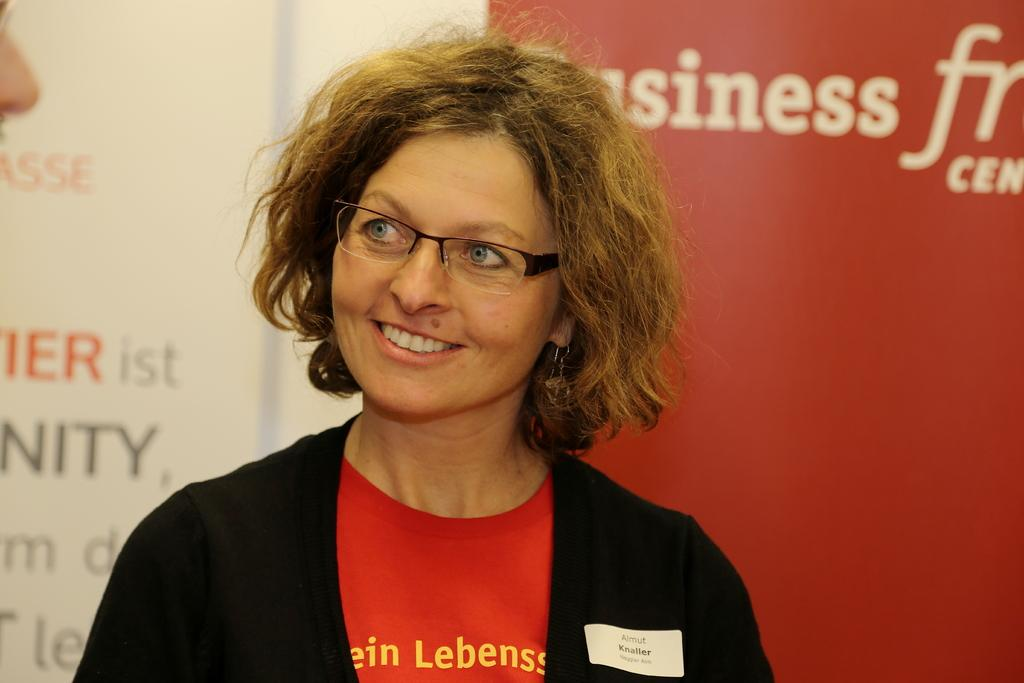Who is present in the image? There is a woman in the image. What is the woman doing in the image? The woman is standing in the image. What is the woman's facial expression in the image? The woman is smiling in the image. What type of clothing is the woman wearing in the image? The woman is wearing a jacket and a T-shirt in the image. What accessory is the woman wearing in the image? The woman is wearing spectacles in the image. What can be seen in the background of the image? There is a banner in the background of the image. How many passengers are waiting in the hospital depicted in the image? There is no hospital or passengers present in the image; it features a woman standing with a banner in the background. 